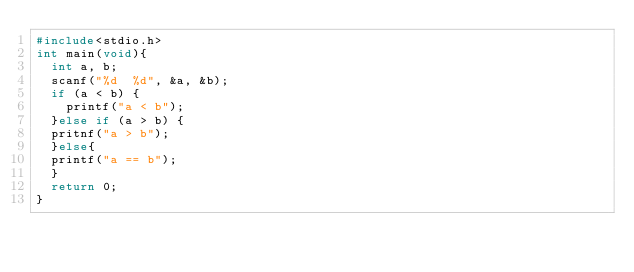<code> <loc_0><loc_0><loc_500><loc_500><_C_>#include<stdio.h>
int main(void){
  int a, b;
  scanf("%d  %d", &a, &b);
  if (a < b) {
  	printf("a < b");
  }else if (a > b) {
	pritnf("a > b");
  }else{
	printf("a == b");
  }
  return 0;
}
</code> 